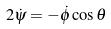<formula> <loc_0><loc_0><loc_500><loc_500>2 \dot { \psi } = - \dot { \phi } \cos \theta</formula> 